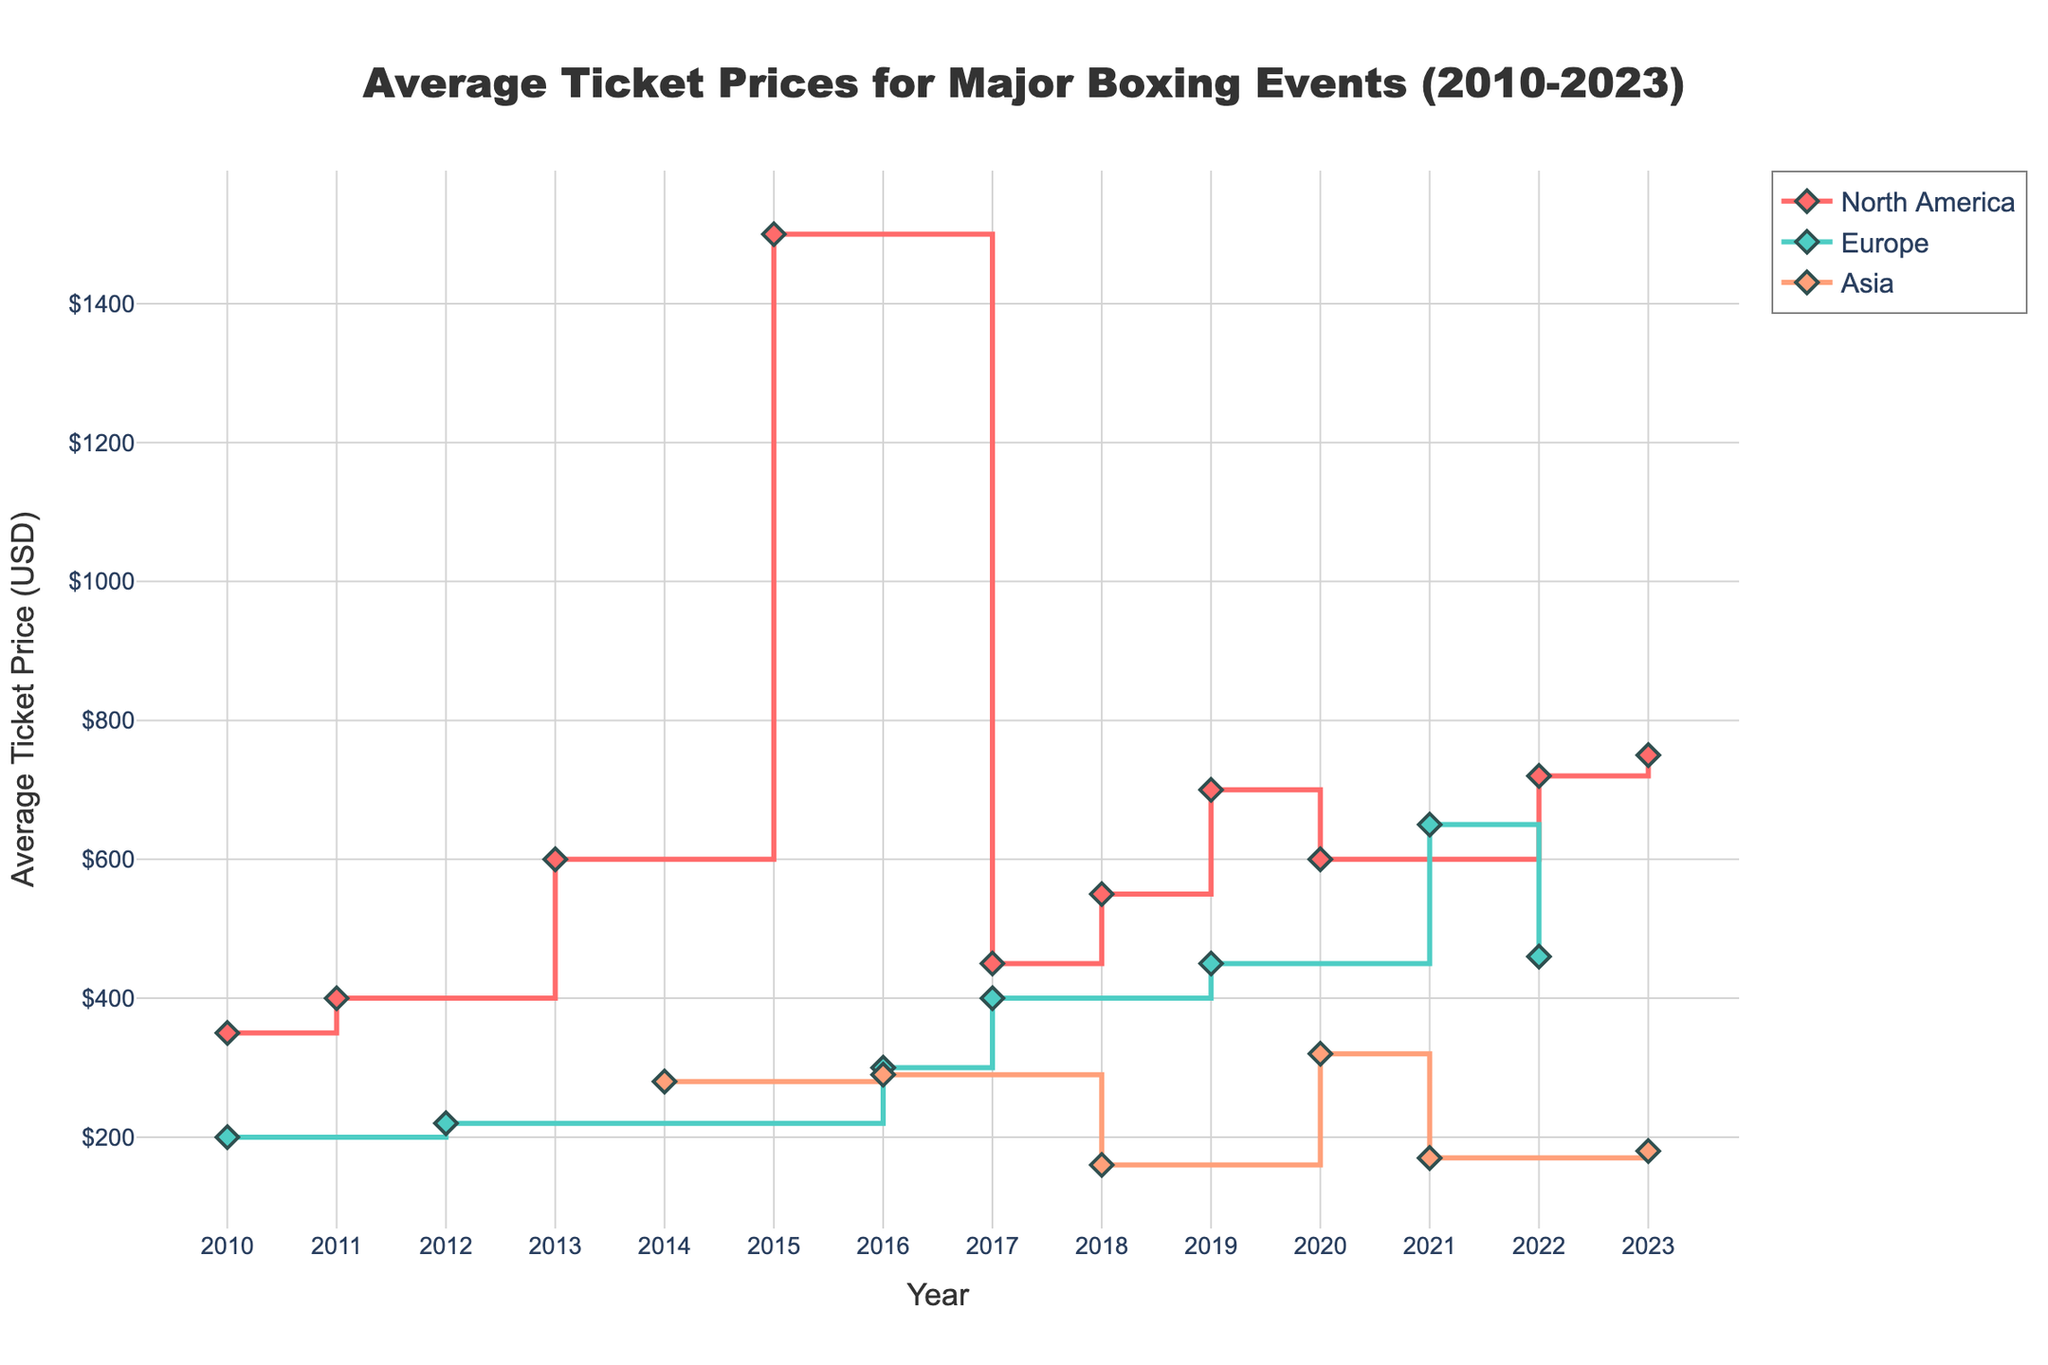How many regions are represented in the plot? The plot has different colors representing the regions. Looking at the legend, there are three regions: North America, Europe, and Asia.
Answer: 3 What is the range of average ticket prices for events held in Asia over the years? To find the range, identify the minimum and maximum average ticket prices for Asia. The minimum is $160 (2018) and the maximum is $320 (2020). Therefore, the range is $320 - $160 = $160.
Answer: $160 Which event had the highest average ticket price, and what was the price? Locate the highest point on the y-axis. This corresponds to the North America region in 2015 for the Floyd Mayweather vs. Manny Pacquiao event with a price of $1500.
Answer: Floyd Mayweather vs. Manny Pacquiao, $1500 Between which consecutive years did North America see the biggest increase in average ticket prices? Review the stair plot for North America and find the largest vertical jump. The biggest increase is from 2014 ($280) to 2015 ($1500), with a difference of $1220.
Answer: 2014 to 2015 How do ticket prices for events in Europe in 2016 compare to 2017? The 2016 price for Europe was $300 (Anthony Joshua vs. Charles Martin), and the 2017 price was $400 (Anthony Joshua vs. Wladimir Klitschko). The 2017 price was $100 higher than 2016.
Answer: 2017 was $100 higher Which region had the lowest average ticket price in 2023 and what was the event? In 2023, Asia had the lowest average ticket price of $180 for Naoya Inoue vs. Paul Butler.
Answer: Asia, Naoya Inoue vs. Paul Butler What is the average ticket price of the events hosted in Europe from 2010 to 2023? Add the average ticket prices for Europe (200, 220, 300, 400, 450, 460, and 650) and divide by the number of events (7). (200+220+300+400+450+460+650)=2680/7≈382.86.
Answer: $382.86 What is the trend observed in average ticket prices in Asia from 2010 to 2023? Observe the stair plot for Asia over the years. Average ticket prices fluctuate with no clear upward or downward trend: $280 (2014), $290 (2016), $160 (2018), $320 (2020), $170 (2021), and $180 (2023).
Answer: Fluctuating What was the average ticket price for North America in 2019, and what was the event? Check the plot for the data point in 2019 for North America. The event was Saul 'Canelo' Alvarez vs. Sergey Kovalev with a price of $700.
Answer: $700, Saul 'Canelo' Alvarez vs. Sergey Kovalev Which two events had the closest average ticket prices in all regions, and what are those prices? Identify events with closely aligned ticket prices across all regions. Manny Pacquiao vs. Timothy Bradley II (2014, Asia) had $280, and Manny Pacquiao vs. Jessie Vargas (2016, Asia) had $290. The prices are $280 and $290, which are closest to each other.
Answer: Manny Pacquiao vs. Timothy Bradley II - $280 and Manny Pacquiao vs. Jessie Vargas - $290 